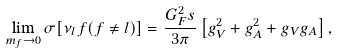Convert formula to latex. <formula><loc_0><loc_0><loc_500><loc_500>\lim _ { m _ { f } \to 0 } \sigma [ \nu _ { l } f ( f \neq l ) ] = \frac { G _ { F } ^ { 2 } s } { 3 \pi } \left [ g _ { V } ^ { 2 } + g _ { A } ^ { 2 } + g _ { V } g _ { A } \right ] ,</formula> 